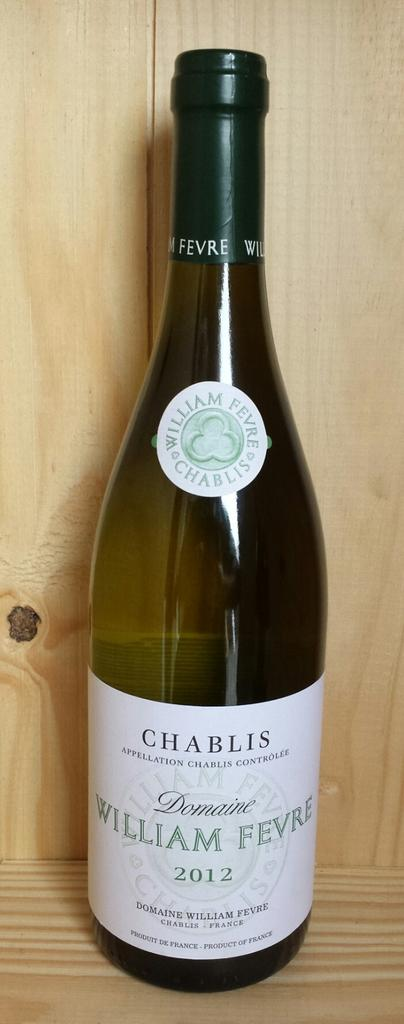Provide a one-sentence caption for the provided image. A bottle of wine marked William Fevre 2012 sits atop a wooden shelf. 